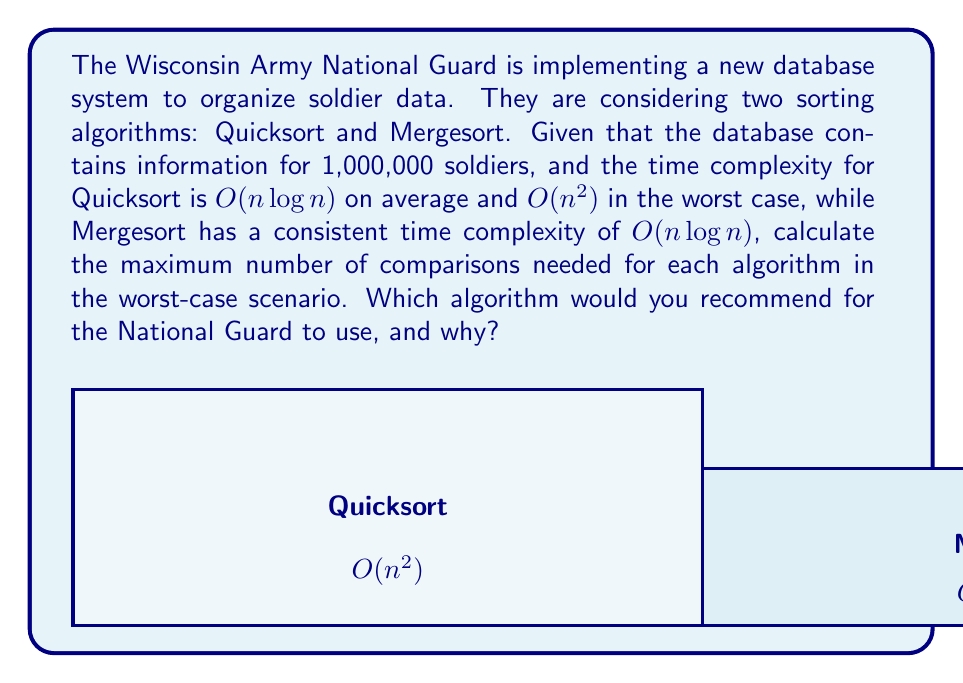Can you solve this math problem? Let's approach this step-by-step:

1) For Quicksort:
   - Worst-case time complexity: $O(n^2)$
   - Number of soldiers (n) = 1,000,000
   - Maximum comparisons = $n^2 = (1,000,000)^2 = 1,000,000,000,000$

2) For Mergesort:
   - Time complexity: $O(n \log n)$
   - Number of soldiers (n) = 1,000,000
   - Maximum comparisons = $n \log_2 n = 1,000,000 \times \log_2(1,000,000)$
   - $\log_2(1,000,000) \approx 19.93$
   - So, maximum comparisons $\approx 1,000,000 \times 19.93 = 19,930,000$

3) Comparison:
   - Quicksort (worst-case): 1,000,000,000,000 comparisons
   - Mergesort: 19,930,000 comparisons

4) Recommendation:
   Mergesort is the better choice for the National Guard because:
   a) It has a consistent performance regardless of the initial order of data.
   b) It requires significantly fewer comparisons in the worst-case scenario.
   c) It's more predictable, which is crucial for military applications where 
      reliability and consistent performance are important.
Answer: Mergesort; 19,930,000 comparisons vs. 1,000,000,000,000 for Quicksort (worst-case). 